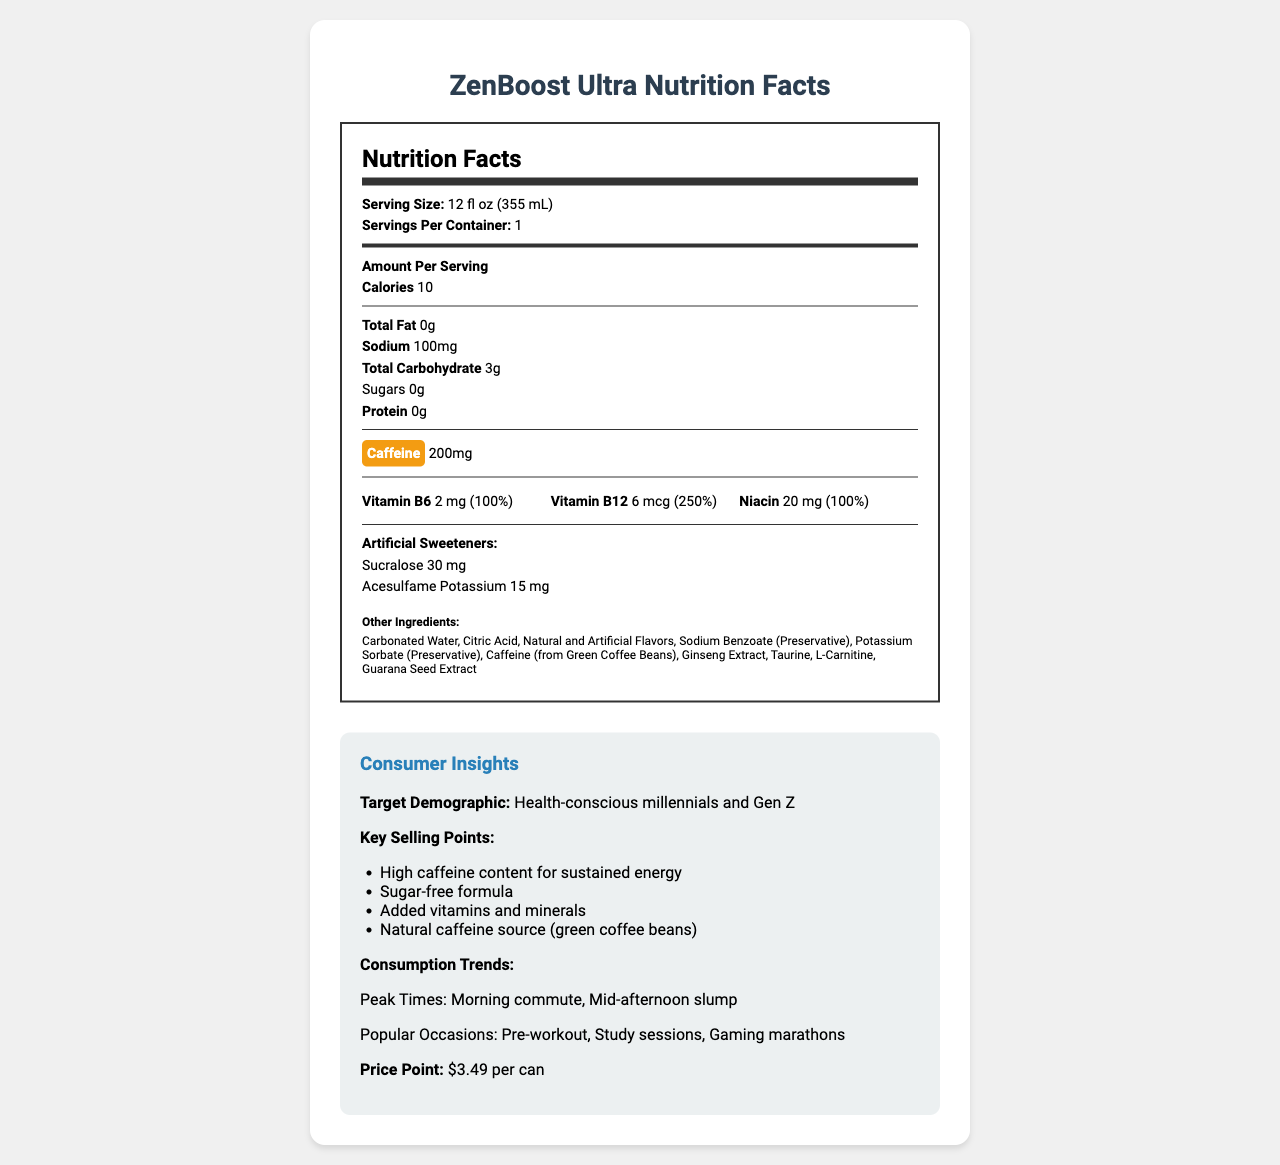what is the name of the product? The name of the product is clearly listed at the top of the document and in the title section as "ZenBoost Ultra".
Answer: ZenBoost Ultra what is the serving size? The serving size is specified under the Nutrition Facts section as "12 fl oz (355 mL)".
Answer: 12 fl oz (355 mL) how much caffeine is in one serving? The caffeine content per serving is highlighted with a yellow background and listed as "200 mg".
Answer: 200 mg how much sodium does one serving contain? Under the Nutrition Facts section, the sodium content per serving is listed as "100 mg".
Answer: 100 mg how many grams of protein are in one serving? The document states that the protein content per serving is "0 g".
Answer: 0 g which artificial sweetener is used more, Sucralose or Acesulfame Potassium? The document lists "Sucralose 30 mg" and "Acesulfame Potassium 15 mg"; thus, Sucralose is used in a higher quantity.
Answer: Sucralose which of these vitamins is present in the highest daily value percentage? A. Vitamin B6 B. Vitamin B12 C. Niacin Vitamin B6 is at 100%, Vitamin B12 is at 250%, and Niacin is at 100%. Therefore, Vitamin B12 has the highest daily value percentage.
Answer: B what are the peak consumption times for ZenBoost Ultra? Under Consumer Insights, the peak times are listed as "Morning commute" and "Mid-afternoon slump".
Answer: Morning commute, Mid-afternoon slump which competitor positions itself as having zero sugar and zero calories? A. Red Bull Sugar Free B. Monster Energy Zero Ultra C. Reign Total Body Fuel Monster Energy Zero Ultra is known for promoting zero sugar and zero calories; hence, it is a competitor with similar positioning.
Answer: B is the product considered sugar-free? The sugars content is listed as "0 g", indicating that the product is sugar-free.
Answer: Yes what are some popular occasions for consuming ZenBoost Ultra? The consumption trends in Consumer Insights list these occasions specifically.
Answer: Pre-workout, Study sessions, Gaming marathons summarize the document in one sentence. The document details multiple aspects of ZenBoost Ultra, including nutritional information, ingredients, target demographics, peak consumption times, and market positioning.
Answer: The document provides an overview of the nutritional facts, ingredients, and consumer insights for ZenBoost Ultra, a trendy energy drink emphasizing high caffeine content, artificial sweeteners, and cognitive-enhancing ingredients. what is the main source of caffeine in ZenBoost Ultra? The section listing "Other Ingredients" includes "Caffeine (from Green Coffee Beans)" specifically.
Answer: Green coffee beans what is the price point of ZenBoost Ultra per can? The Consumer Insights section lists the price point as "$3.49 per can".
Answer: $3.49 per can how many servings are there per container? The document states that there is "1" serving per container as listed under the Nutrition Facts section.
Answer: 1 what are the two main preservatives used in ZenBoost Ultra? The "Other Ingredients" section lists these two preservatives.
Answer: Sodium Benzoate, Potassium Sorbate how many calories does one serving of ZenBoost Ultra contain? Under the Nutrition Facts section, the number of calories per serving is listed as "10".
Answer: 10 what is the daily value percentage of Vitamin B6 in one serving? The Vitamin B6 is listed under the vitamins and minerals section with a daily value of 100%.
Answer: 100% how much Taurine is in ZenBoost Ultra? The document lists Taurine as one of the other ingredients but does not specify the amount, so the exact quantity cannot be determined.
Answer: Not enough information 